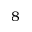<formula> <loc_0><loc_0><loc_500><loc_500>8</formula> 